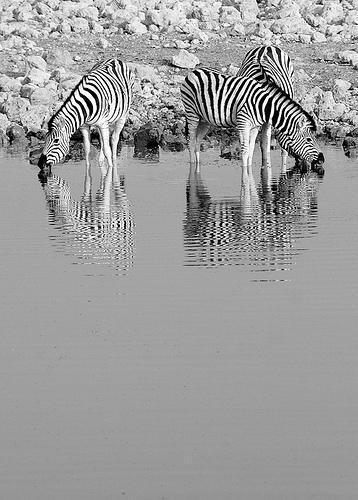How many zebras are in the picture?
Give a very brief answer. 3. How many zebras are shown?
Give a very brief answer. 3. How many heads are visible?
Give a very brief answer. 2. How many zebras are on the right side?
Give a very brief answer. 2. How many zebras are on the left side?
Give a very brief answer. 1. 